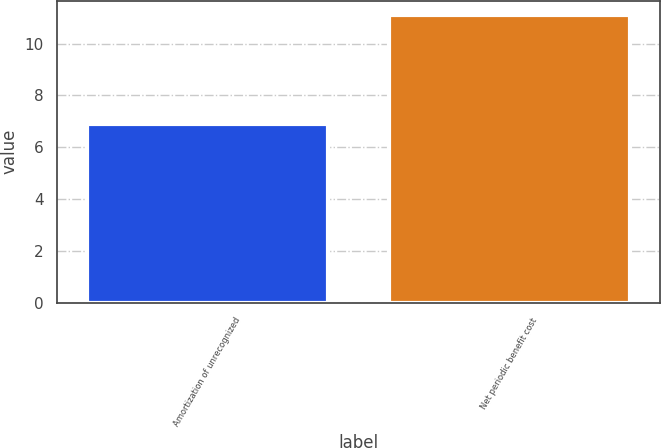<chart> <loc_0><loc_0><loc_500><loc_500><bar_chart><fcel>Amortization of unrecognized<fcel>Net periodic benefit cost<nl><fcel>6.9<fcel>11.1<nl></chart> 